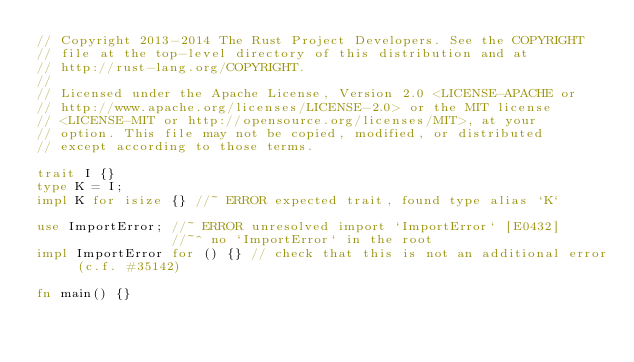<code> <loc_0><loc_0><loc_500><loc_500><_Rust_>// Copyright 2013-2014 The Rust Project Developers. See the COPYRIGHT
// file at the top-level directory of this distribution and at
// http://rust-lang.org/COPYRIGHT.
//
// Licensed under the Apache License, Version 2.0 <LICENSE-APACHE or
// http://www.apache.org/licenses/LICENSE-2.0> or the MIT license
// <LICENSE-MIT or http://opensource.org/licenses/MIT>, at your
// option. This file may not be copied, modified, or distributed
// except according to those terms.

trait I {}
type K = I;
impl K for isize {} //~ ERROR expected trait, found type alias `K`

use ImportError; //~ ERROR unresolved import `ImportError` [E0432]
                 //~^ no `ImportError` in the root
impl ImportError for () {} // check that this is not an additional error (c.f. #35142)

fn main() {}
</code> 